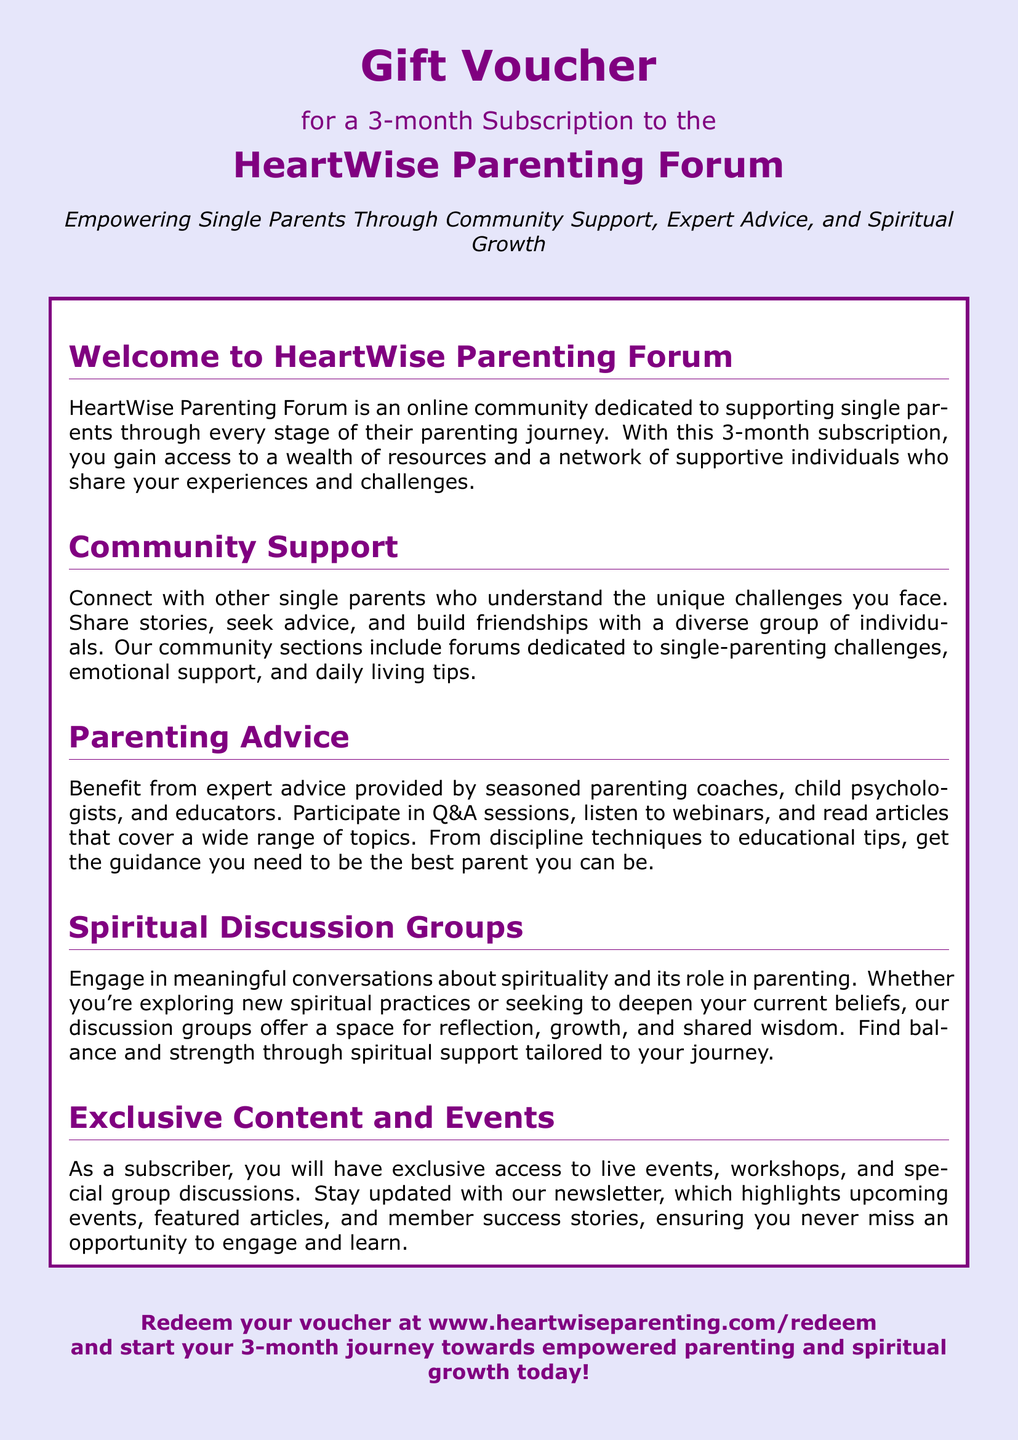What does this voucher provide? The voucher provides a 3-month subscription to the HeartWise Parenting Forum.
Answer: 3-month subscription What is the forum dedicated to? The forum is dedicated to supporting single parents.
Answer: supporting single parents What type of advice can subscribers benefit from? Subscribers can benefit from expert advice.
Answer: expert advice What kind of groups are available for discussion? Spiritual discussion groups are available.
Answer: Spiritual discussion groups Where can the voucher be redeemed? The voucher can be redeemed at a specific website.
Answer: www.heartwiseparenting.com/redeem Who can connect in the community support section? Single parents can connect in the community support section.
Answer: Single parents What are two topics covered in parenting advice? The topics include discipline techniques and educational tips.
Answer: discipline techniques, educational tips What does the subscription include that enhances engagement? The subscription includes access to exclusive content and events.
Answer: exclusive content and events What is emphasized as a benefit of the spiritual groups? The spiritual groups emphasize meaningful conversations.
Answer: meaningful conversations 